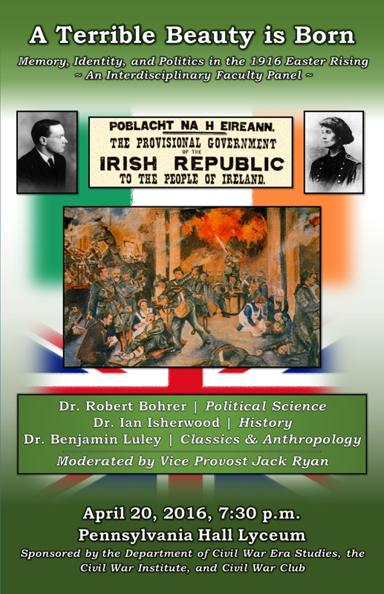Which organizations sponsor the panel? This enlightening panel is proudly sponsored by the Department of Civil War Era Studies, the Civil War Institute, and the Civil War Club. These organizations collectively focus on historical studies and provide a robust platform for academic discussions like this one. 